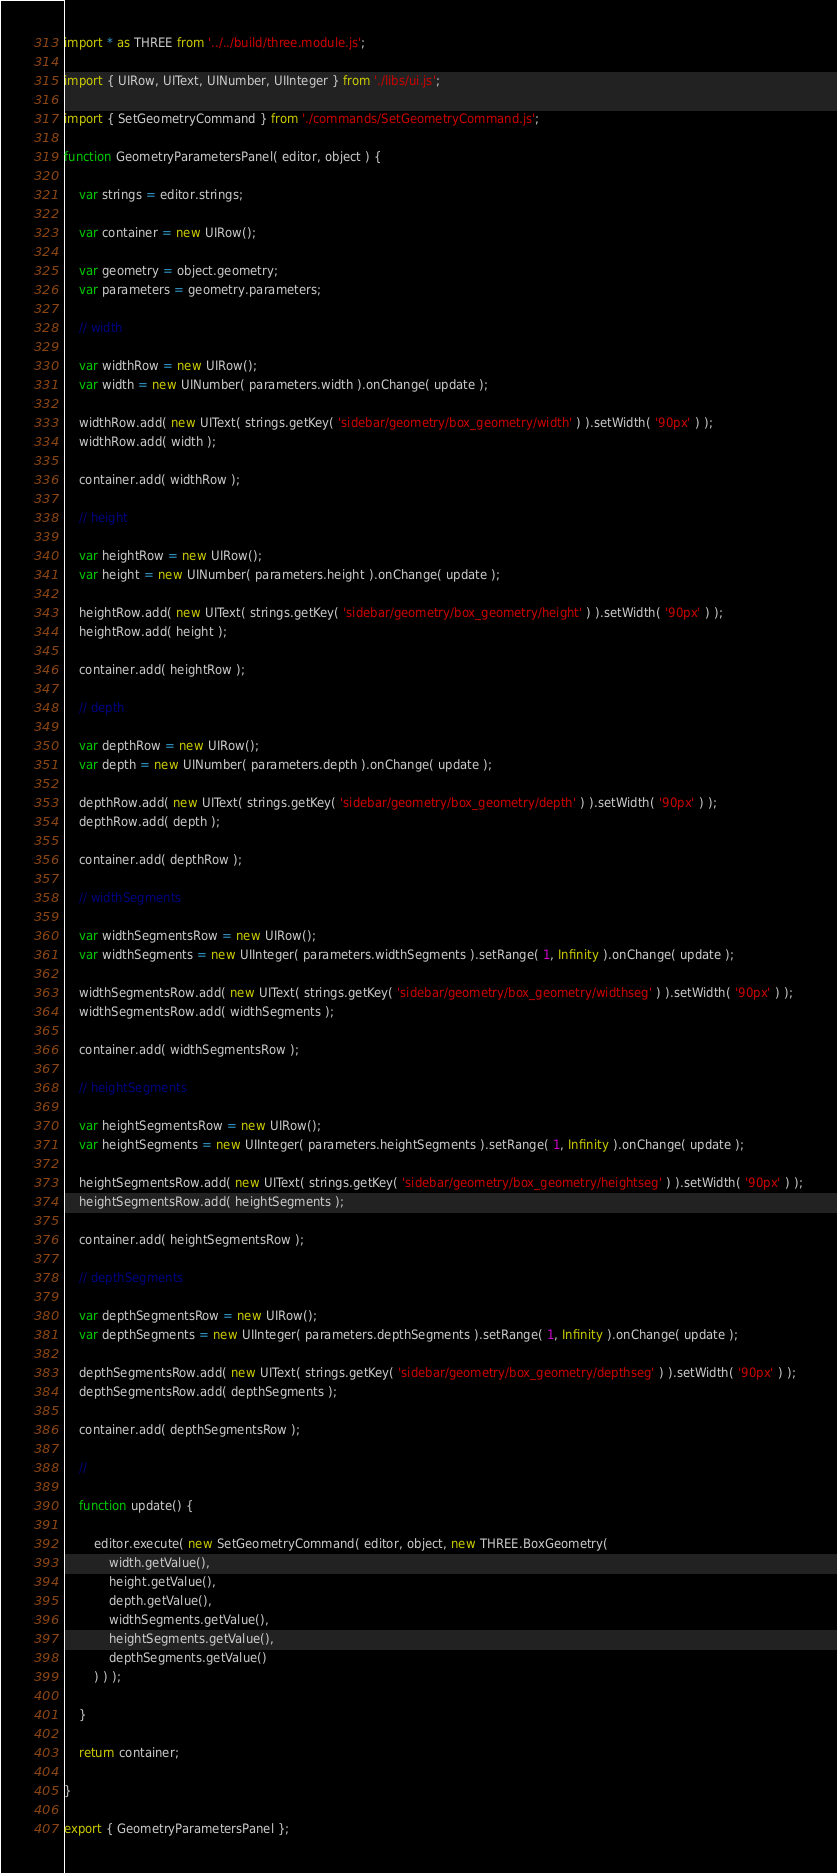<code> <loc_0><loc_0><loc_500><loc_500><_JavaScript_>import * as THREE from '../../build/three.module.js';

import { UIRow, UIText, UINumber, UIInteger } from './libs/ui.js';

import { SetGeometryCommand } from './commands/SetGeometryCommand.js';

function GeometryParametersPanel( editor, object ) {

	var strings = editor.strings;

	var container = new UIRow();

	var geometry = object.geometry;
	var parameters = geometry.parameters;

	// width

	var widthRow = new UIRow();
	var width = new UINumber( parameters.width ).onChange( update );

	widthRow.add( new UIText( strings.getKey( 'sidebar/geometry/box_geometry/width' ) ).setWidth( '90px' ) );
	widthRow.add( width );

	container.add( widthRow );

	// height

	var heightRow = new UIRow();
	var height = new UINumber( parameters.height ).onChange( update );

	heightRow.add( new UIText( strings.getKey( 'sidebar/geometry/box_geometry/height' ) ).setWidth( '90px' ) );
	heightRow.add( height );

	container.add( heightRow );

	// depth

	var depthRow = new UIRow();
	var depth = new UINumber( parameters.depth ).onChange( update );

	depthRow.add( new UIText( strings.getKey( 'sidebar/geometry/box_geometry/depth' ) ).setWidth( '90px' ) );
	depthRow.add( depth );

	container.add( depthRow );

	// widthSegments

	var widthSegmentsRow = new UIRow();
	var widthSegments = new UIInteger( parameters.widthSegments ).setRange( 1, Infinity ).onChange( update );

	widthSegmentsRow.add( new UIText( strings.getKey( 'sidebar/geometry/box_geometry/widthseg' ) ).setWidth( '90px' ) );
	widthSegmentsRow.add( widthSegments );

	container.add( widthSegmentsRow );

	// heightSegments

	var heightSegmentsRow = new UIRow();
	var heightSegments = new UIInteger( parameters.heightSegments ).setRange( 1, Infinity ).onChange( update );

	heightSegmentsRow.add( new UIText( strings.getKey( 'sidebar/geometry/box_geometry/heightseg' ) ).setWidth( '90px' ) );
	heightSegmentsRow.add( heightSegments );

	container.add( heightSegmentsRow );

	// depthSegments

	var depthSegmentsRow = new UIRow();
	var depthSegments = new UIInteger( parameters.depthSegments ).setRange( 1, Infinity ).onChange( update );

	depthSegmentsRow.add( new UIText( strings.getKey( 'sidebar/geometry/box_geometry/depthseg' ) ).setWidth( '90px' ) );
	depthSegmentsRow.add( depthSegments );

	container.add( depthSegmentsRow );

	//

	function update() {

		editor.execute( new SetGeometryCommand( editor, object, new THREE.BoxGeometry(
			width.getValue(),
			height.getValue(),
			depth.getValue(),
			widthSegments.getValue(),
			heightSegments.getValue(),
			depthSegments.getValue()
		) ) );

	}

	return container;

}

export { GeometryParametersPanel };
</code> 